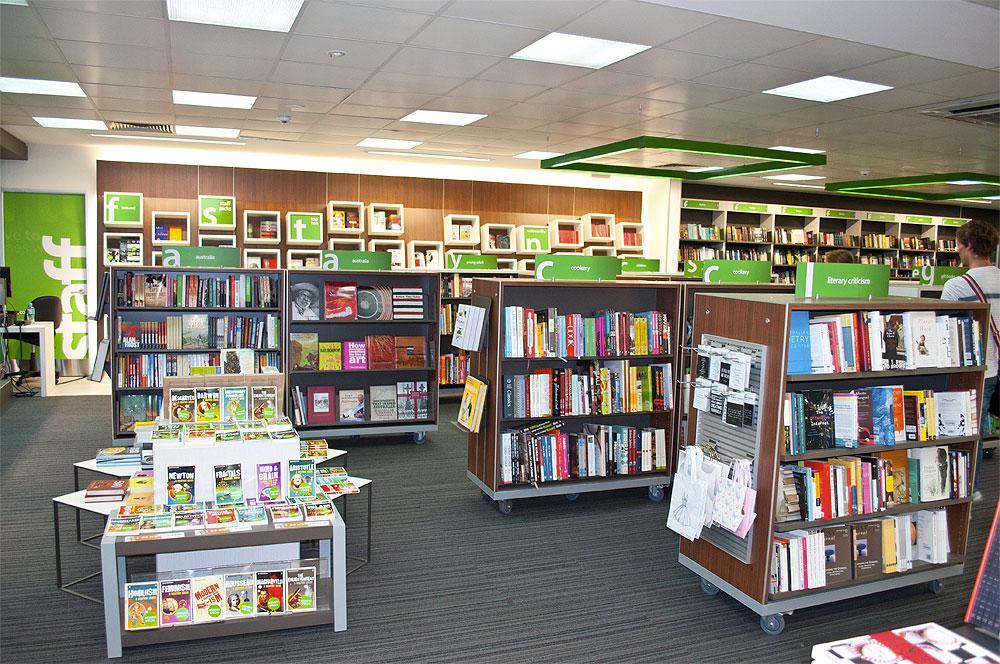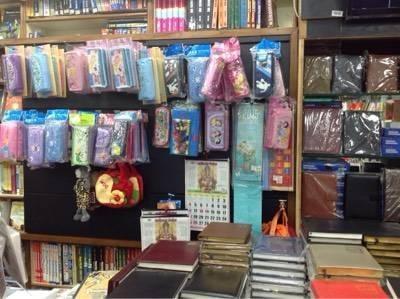The first image is the image on the left, the second image is the image on the right. Assess this claim about the two images: "All of the people in the shop are men.". Correct or not? Answer yes or no. No. 